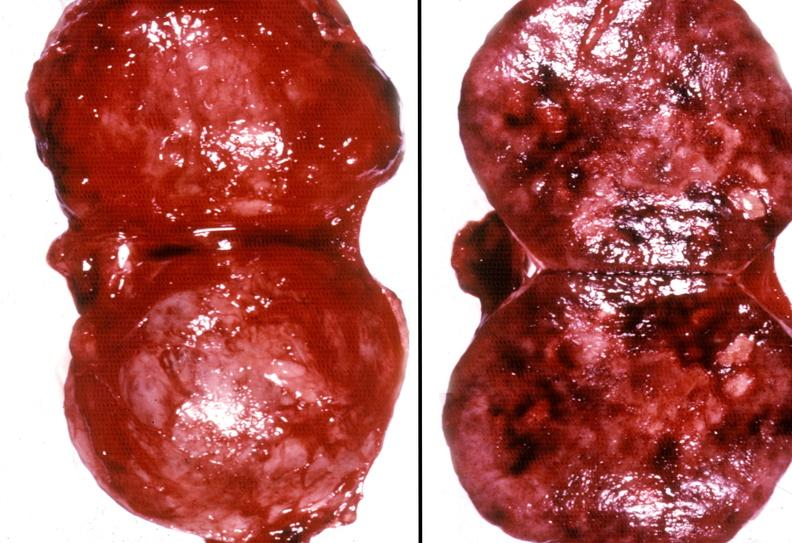does fibrinous peritonitis show adrenal phaeochromocytoma?
Answer the question using a single word or phrase. No 